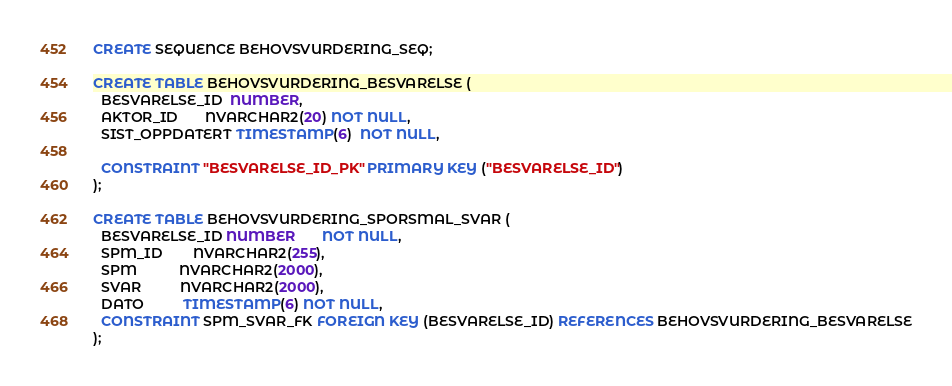<code> <loc_0><loc_0><loc_500><loc_500><_SQL_>CREATE SEQUENCE BEHOVSVURDERING_SEQ;

CREATE TABLE BEHOVSVURDERING_BESVARELSE (
  BESVARELSE_ID  NUMBER,
  AKTOR_ID       NVARCHAR2(20) NOT NULL,
  SIST_OPPDATERT TIMESTAMP(6)  NOT NULL,

  CONSTRAINT "BESVARELSE_ID_PK" PRIMARY KEY ("BESVARELSE_ID")
);

CREATE TABLE BEHOVSVURDERING_SPORSMAL_SVAR (
  BESVARELSE_ID NUMBER       NOT NULL,
  SPM_ID        NVARCHAR2(255),
  SPM           NVARCHAR2(2000),
  SVAR          NVARCHAR2(2000),
  DATO          TIMESTAMP(6) NOT NULL,
  CONSTRAINT SPM_SVAR_FK FOREIGN KEY (BESVARELSE_ID) REFERENCES BEHOVSVURDERING_BESVARELSE
);
</code> 